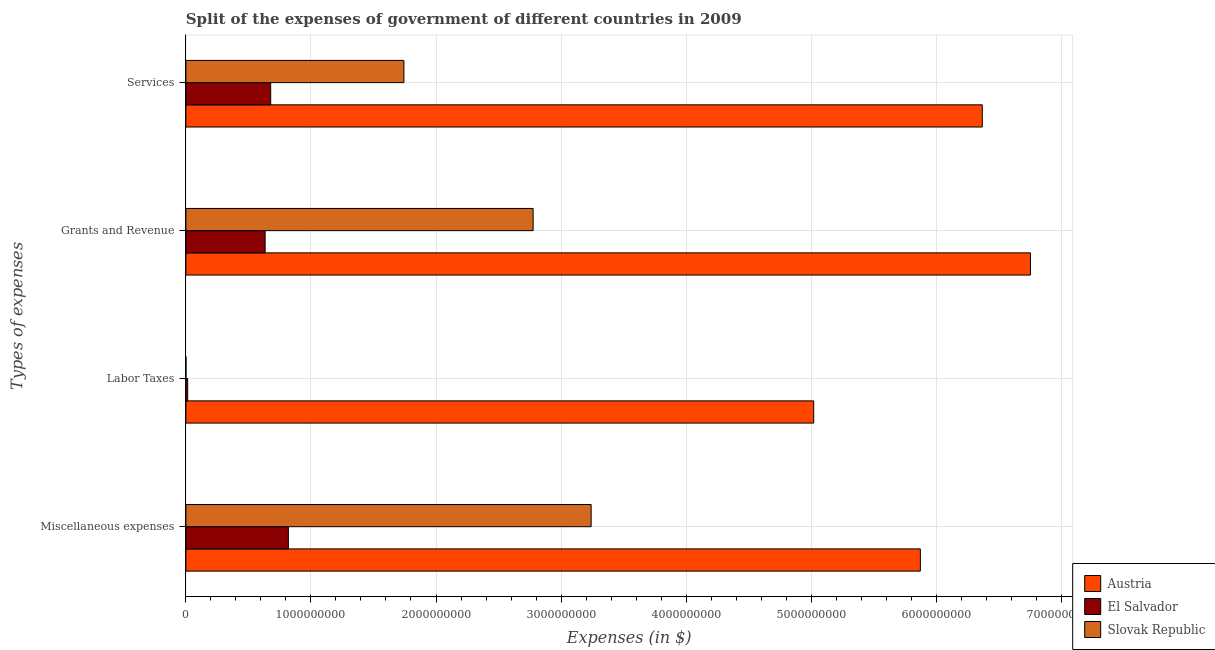How many different coloured bars are there?
Provide a short and direct response. 3. How many groups of bars are there?
Make the answer very short. 4. Are the number of bars per tick equal to the number of legend labels?
Your answer should be very brief. Yes. Are the number of bars on each tick of the Y-axis equal?
Offer a terse response. Yes. How many bars are there on the 4th tick from the bottom?
Offer a very short reply. 3. What is the label of the 4th group of bars from the top?
Give a very brief answer. Miscellaneous expenses. What is the amount spent on miscellaneous expenses in Austria?
Make the answer very short. 5.87e+09. Across all countries, what is the maximum amount spent on miscellaneous expenses?
Provide a short and direct response. 5.87e+09. Across all countries, what is the minimum amount spent on grants and revenue?
Provide a short and direct response. 6.34e+08. In which country was the amount spent on grants and revenue maximum?
Give a very brief answer. Austria. In which country was the amount spent on labor taxes minimum?
Give a very brief answer. Slovak Republic. What is the total amount spent on services in the graph?
Give a very brief answer. 8.79e+09. What is the difference between the amount spent on services in El Salvador and that in Austria?
Keep it short and to the point. -5.69e+09. What is the difference between the amount spent on miscellaneous expenses in Austria and the amount spent on services in Slovak Republic?
Give a very brief answer. 4.13e+09. What is the average amount spent on services per country?
Ensure brevity in your answer.  2.93e+09. What is the difference between the amount spent on labor taxes and amount spent on miscellaneous expenses in Slovak Republic?
Keep it short and to the point. -3.24e+09. What is the ratio of the amount spent on services in El Salvador to that in Slovak Republic?
Your answer should be compact. 0.39. Is the difference between the amount spent on grants and revenue in Slovak Republic and Austria greater than the difference between the amount spent on miscellaneous expenses in Slovak Republic and Austria?
Keep it short and to the point. No. What is the difference between the highest and the second highest amount spent on labor taxes?
Give a very brief answer. 5.01e+09. What is the difference between the highest and the lowest amount spent on labor taxes?
Offer a very short reply. 5.02e+09. In how many countries, is the amount spent on grants and revenue greater than the average amount spent on grants and revenue taken over all countries?
Offer a very short reply. 1. What does the 2nd bar from the top in Labor Taxes represents?
Your answer should be compact. El Salvador. What does the 2nd bar from the bottom in Labor Taxes represents?
Offer a very short reply. El Salvador. Is it the case that in every country, the sum of the amount spent on miscellaneous expenses and amount spent on labor taxes is greater than the amount spent on grants and revenue?
Provide a succinct answer. Yes. How many bars are there?
Provide a short and direct response. 12. Are all the bars in the graph horizontal?
Provide a succinct answer. Yes. How many countries are there in the graph?
Your answer should be compact. 3. What is the difference between two consecutive major ticks on the X-axis?
Your answer should be very brief. 1.00e+09. Are the values on the major ticks of X-axis written in scientific E-notation?
Keep it short and to the point. No. Does the graph contain any zero values?
Offer a terse response. No. How are the legend labels stacked?
Your response must be concise. Vertical. What is the title of the graph?
Your response must be concise. Split of the expenses of government of different countries in 2009. What is the label or title of the X-axis?
Ensure brevity in your answer.  Expenses (in $). What is the label or title of the Y-axis?
Offer a very short reply. Types of expenses. What is the Expenses (in $) of Austria in Miscellaneous expenses?
Offer a very short reply. 5.87e+09. What is the Expenses (in $) of El Salvador in Miscellaneous expenses?
Your answer should be compact. 8.19e+08. What is the Expenses (in $) of Slovak Republic in Miscellaneous expenses?
Give a very brief answer. 3.24e+09. What is the Expenses (in $) of Austria in Labor Taxes?
Your answer should be very brief. 5.02e+09. What is the Expenses (in $) in El Salvador in Labor Taxes?
Provide a succinct answer. 1.42e+07. What is the Expenses (in $) in Slovak Republic in Labor Taxes?
Offer a very short reply. 7.25e+05. What is the Expenses (in $) in Austria in Grants and Revenue?
Give a very brief answer. 6.75e+09. What is the Expenses (in $) in El Salvador in Grants and Revenue?
Your answer should be compact. 6.34e+08. What is the Expenses (in $) in Slovak Republic in Grants and Revenue?
Make the answer very short. 2.78e+09. What is the Expenses (in $) in Austria in Services?
Your answer should be very brief. 6.37e+09. What is the Expenses (in $) in El Salvador in Services?
Ensure brevity in your answer.  6.78e+08. What is the Expenses (in $) in Slovak Republic in Services?
Provide a short and direct response. 1.74e+09. Across all Types of expenses, what is the maximum Expenses (in $) of Austria?
Provide a short and direct response. 6.75e+09. Across all Types of expenses, what is the maximum Expenses (in $) in El Salvador?
Your answer should be compact. 8.19e+08. Across all Types of expenses, what is the maximum Expenses (in $) in Slovak Republic?
Give a very brief answer. 3.24e+09. Across all Types of expenses, what is the minimum Expenses (in $) in Austria?
Your answer should be very brief. 5.02e+09. Across all Types of expenses, what is the minimum Expenses (in $) of El Salvador?
Make the answer very short. 1.42e+07. Across all Types of expenses, what is the minimum Expenses (in $) in Slovak Republic?
Make the answer very short. 7.25e+05. What is the total Expenses (in $) in Austria in the graph?
Ensure brevity in your answer.  2.40e+1. What is the total Expenses (in $) in El Salvador in the graph?
Offer a terse response. 2.15e+09. What is the total Expenses (in $) in Slovak Republic in the graph?
Keep it short and to the point. 7.76e+09. What is the difference between the Expenses (in $) of Austria in Miscellaneous expenses and that in Labor Taxes?
Your answer should be compact. 8.53e+08. What is the difference between the Expenses (in $) of El Salvador in Miscellaneous expenses and that in Labor Taxes?
Make the answer very short. 8.05e+08. What is the difference between the Expenses (in $) in Slovak Republic in Miscellaneous expenses and that in Labor Taxes?
Keep it short and to the point. 3.24e+09. What is the difference between the Expenses (in $) of Austria in Miscellaneous expenses and that in Grants and Revenue?
Give a very brief answer. -8.80e+08. What is the difference between the Expenses (in $) of El Salvador in Miscellaneous expenses and that in Grants and Revenue?
Your answer should be compact. 1.86e+08. What is the difference between the Expenses (in $) of Slovak Republic in Miscellaneous expenses and that in Grants and Revenue?
Offer a terse response. 4.64e+08. What is the difference between the Expenses (in $) in Austria in Miscellaneous expenses and that in Services?
Give a very brief answer. -4.95e+08. What is the difference between the Expenses (in $) in El Salvador in Miscellaneous expenses and that in Services?
Provide a short and direct response. 1.41e+08. What is the difference between the Expenses (in $) of Slovak Republic in Miscellaneous expenses and that in Services?
Provide a short and direct response. 1.50e+09. What is the difference between the Expenses (in $) of Austria in Labor Taxes and that in Grants and Revenue?
Give a very brief answer. -1.73e+09. What is the difference between the Expenses (in $) in El Salvador in Labor Taxes and that in Grants and Revenue?
Give a very brief answer. -6.20e+08. What is the difference between the Expenses (in $) in Slovak Republic in Labor Taxes and that in Grants and Revenue?
Your answer should be very brief. -2.78e+09. What is the difference between the Expenses (in $) in Austria in Labor Taxes and that in Services?
Your response must be concise. -1.35e+09. What is the difference between the Expenses (in $) of El Salvador in Labor Taxes and that in Services?
Keep it short and to the point. -6.64e+08. What is the difference between the Expenses (in $) of Slovak Republic in Labor Taxes and that in Services?
Your answer should be very brief. -1.74e+09. What is the difference between the Expenses (in $) of Austria in Grants and Revenue and that in Services?
Provide a short and direct response. 3.85e+08. What is the difference between the Expenses (in $) of El Salvador in Grants and Revenue and that in Services?
Your response must be concise. -4.45e+07. What is the difference between the Expenses (in $) in Slovak Republic in Grants and Revenue and that in Services?
Provide a short and direct response. 1.03e+09. What is the difference between the Expenses (in $) of Austria in Miscellaneous expenses and the Expenses (in $) of El Salvador in Labor Taxes?
Keep it short and to the point. 5.86e+09. What is the difference between the Expenses (in $) in Austria in Miscellaneous expenses and the Expenses (in $) in Slovak Republic in Labor Taxes?
Your response must be concise. 5.87e+09. What is the difference between the Expenses (in $) of El Salvador in Miscellaneous expenses and the Expenses (in $) of Slovak Republic in Labor Taxes?
Make the answer very short. 8.19e+08. What is the difference between the Expenses (in $) of Austria in Miscellaneous expenses and the Expenses (in $) of El Salvador in Grants and Revenue?
Provide a succinct answer. 5.24e+09. What is the difference between the Expenses (in $) in Austria in Miscellaneous expenses and the Expenses (in $) in Slovak Republic in Grants and Revenue?
Offer a very short reply. 3.10e+09. What is the difference between the Expenses (in $) of El Salvador in Miscellaneous expenses and the Expenses (in $) of Slovak Republic in Grants and Revenue?
Your response must be concise. -1.96e+09. What is the difference between the Expenses (in $) of Austria in Miscellaneous expenses and the Expenses (in $) of El Salvador in Services?
Offer a terse response. 5.19e+09. What is the difference between the Expenses (in $) in Austria in Miscellaneous expenses and the Expenses (in $) in Slovak Republic in Services?
Give a very brief answer. 4.13e+09. What is the difference between the Expenses (in $) in El Salvador in Miscellaneous expenses and the Expenses (in $) in Slovak Republic in Services?
Give a very brief answer. -9.24e+08. What is the difference between the Expenses (in $) in Austria in Labor Taxes and the Expenses (in $) in El Salvador in Grants and Revenue?
Offer a very short reply. 4.39e+09. What is the difference between the Expenses (in $) of Austria in Labor Taxes and the Expenses (in $) of Slovak Republic in Grants and Revenue?
Your answer should be compact. 2.24e+09. What is the difference between the Expenses (in $) of El Salvador in Labor Taxes and the Expenses (in $) of Slovak Republic in Grants and Revenue?
Offer a terse response. -2.76e+09. What is the difference between the Expenses (in $) in Austria in Labor Taxes and the Expenses (in $) in El Salvador in Services?
Your answer should be very brief. 4.34e+09. What is the difference between the Expenses (in $) in Austria in Labor Taxes and the Expenses (in $) in Slovak Republic in Services?
Provide a short and direct response. 3.28e+09. What is the difference between the Expenses (in $) in El Salvador in Labor Taxes and the Expenses (in $) in Slovak Republic in Services?
Your answer should be very brief. -1.73e+09. What is the difference between the Expenses (in $) in Austria in Grants and Revenue and the Expenses (in $) in El Salvador in Services?
Ensure brevity in your answer.  6.08e+09. What is the difference between the Expenses (in $) in Austria in Grants and Revenue and the Expenses (in $) in Slovak Republic in Services?
Your answer should be very brief. 5.01e+09. What is the difference between the Expenses (in $) in El Salvador in Grants and Revenue and the Expenses (in $) in Slovak Republic in Services?
Your answer should be very brief. -1.11e+09. What is the average Expenses (in $) of Austria per Types of expenses?
Offer a very short reply. 6.00e+09. What is the average Expenses (in $) in El Salvador per Types of expenses?
Keep it short and to the point. 5.36e+08. What is the average Expenses (in $) in Slovak Republic per Types of expenses?
Ensure brevity in your answer.  1.94e+09. What is the difference between the Expenses (in $) in Austria and Expenses (in $) in El Salvador in Miscellaneous expenses?
Offer a terse response. 5.05e+09. What is the difference between the Expenses (in $) of Austria and Expenses (in $) of Slovak Republic in Miscellaneous expenses?
Make the answer very short. 2.63e+09. What is the difference between the Expenses (in $) of El Salvador and Expenses (in $) of Slovak Republic in Miscellaneous expenses?
Give a very brief answer. -2.42e+09. What is the difference between the Expenses (in $) in Austria and Expenses (in $) in El Salvador in Labor Taxes?
Your answer should be very brief. 5.01e+09. What is the difference between the Expenses (in $) in Austria and Expenses (in $) in Slovak Republic in Labor Taxes?
Your response must be concise. 5.02e+09. What is the difference between the Expenses (in $) of El Salvador and Expenses (in $) of Slovak Republic in Labor Taxes?
Provide a succinct answer. 1.35e+07. What is the difference between the Expenses (in $) in Austria and Expenses (in $) in El Salvador in Grants and Revenue?
Ensure brevity in your answer.  6.12e+09. What is the difference between the Expenses (in $) in Austria and Expenses (in $) in Slovak Republic in Grants and Revenue?
Your response must be concise. 3.98e+09. What is the difference between the Expenses (in $) in El Salvador and Expenses (in $) in Slovak Republic in Grants and Revenue?
Ensure brevity in your answer.  -2.14e+09. What is the difference between the Expenses (in $) of Austria and Expenses (in $) of El Salvador in Services?
Provide a short and direct response. 5.69e+09. What is the difference between the Expenses (in $) in Austria and Expenses (in $) in Slovak Republic in Services?
Ensure brevity in your answer.  4.62e+09. What is the difference between the Expenses (in $) of El Salvador and Expenses (in $) of Slovak Republic in Services?
Offer a terse response. -1.07e+09. What is the ratio of the Expenses (in $) of Austria in Miscellaneous expenses to that in Labor Taxes?
Keep it short and to the point. 1.17. What is the ratio of the Expenses (in $) in El Salvador in Miscellaneous expenses to that in Labor Taxes?
Your response must be concise. 57.7. What is the ratio of the Expenses (in $) in Slovak Republic in Miscellaneous expenses to that in Labor Taxes?
Your answer should be compact. 4469.93. What is the ratio of the Expenses (in $) in Austria in Miscellaneous expenses to that in Grants and Revenue?
Keep it short and to the point. 0.87. What is the ratio of the Expenses (in $) of El Salvador in Miscellaneous expenses to that in Grants and Revenue?
Provide a short and direct response. 1.29. What is the ratio of the Expenses (in $) of Slovak Republic in Miscellaneous expenses to that in Grants and Revenue?
Keep it short and to the point. 1.17. What is the ratio of the Expenses (in $) of Austria in Miscellaneous expenses to that in Services?
Offer a very short reply. 0.92. What is the ratio of the Expenses (in $) in El Salvador in Miscellaneous expenses to that in Services?
Give a very brief answer. 1.21. What is the ratio of the Expenses (in $) in Slovak Republic in Miscellaneous expenses to that in Services?
Provide a short and direct response. 1.86. What is the ratio of the Expenses (in $) in Austria in Labor Taxes to that in Grants and Revenue?
Provide a succinct answer. 0.74. What is the ratio of the Expenses (in $) of El Salvador in Labor Taxes to that in Grants and Revenue?
Offer a terse response. 0.02. What is the ratio of the Expenses (in $) in Slovak Republic in Labor Taxes to that in Grants and Revenue?
Give a very brief answer. 0. What is the ratio of the Expenses (in $) of Austria in Labor Taxes to that in Services?
Offer a terse response. 0.79. What is the ratio of the Expenses (in $) of El Salvador in Labor Taxes to that in Services?
Your answer should be very brief. 0.02. What is the ratio of the Expenses (in $) in Slovak Republic in Labor Taxes to that in Services?
Your answer should be very brief. 0. What is the ratio of the Expenses (in $) in Austria in Grants and Revenue to that in Services?
Your answer should be very brief. 1.06. What is the ratio of the Expenses (in $) of El Salvador in Grants and Revenue to that in Services?
Give a very brief answer. 0.93. What is the ratio of the Expenses (in $) in Slovak Republic in Grants and Revenue to that in Services?
Your answer should be very brief. 1.59. What is the difference between the highest and the second highest Expenses (in $) in Austria?
Provide a succinct answer. 3.85e+08. What is the difference between the highest and the second highest Expenses (in $) of El Salvador?
Your answer should be very brief. 1.41e+08. What is the difference between the highest and the second highest Expenses (in $) in Slovak Republic?
Ensure brevity in your answer.  4.64e+08. What is the difference between the highest and the lowest Expenses (in $) in Austria?
Give a very brief answer. 1.73e+09. What is the difference between the highest and the lowest Expenses (in $) of El Salvador?
Provide a short and direct response. 8.05e+08. What is the difference between the highest and the lowest Expenses (in $) of Slovak Republic?
Provide a short and direct response. 3.24e+09. 